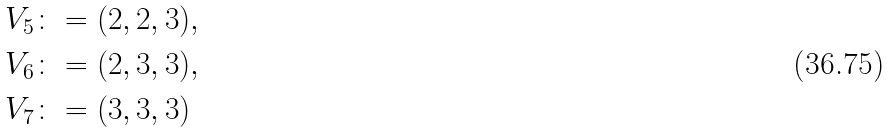<formula> <loc_0><loc_0><loc_500><loc_500>V _ { 5 } & \colon = ( 2 , 2 , 3 ) , \\ V _ { 6 } & \colon = ( 2 , 3 , 3 ) , \\ V _ { 7 } & \colon = ( 3 , 3 , 3 )</formula> 